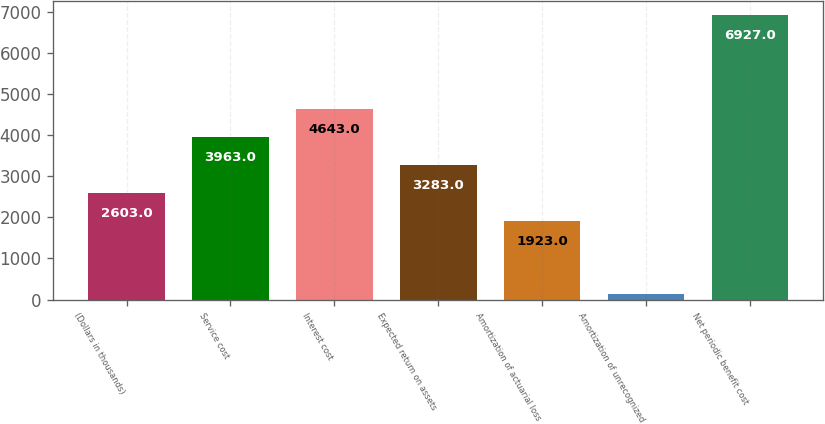Convert chart to OTSL. <chart><loc_0><loc_0><loc_500><loc_500><bar_chart><fcel>(Dollars in thousands)<fcel>Service cost<fcel>Interest cost<fcel>Expected return on assets<fcel>Amortization of actuarial loss<fcel>Amortization of unrecognized<fcel>Net periodic benefit cost<nl><fcel>2603<fcel>3963<fcel>4643<fcel>3283<fcel>1923<fcel>127<fcel>6927<nl></chart> 